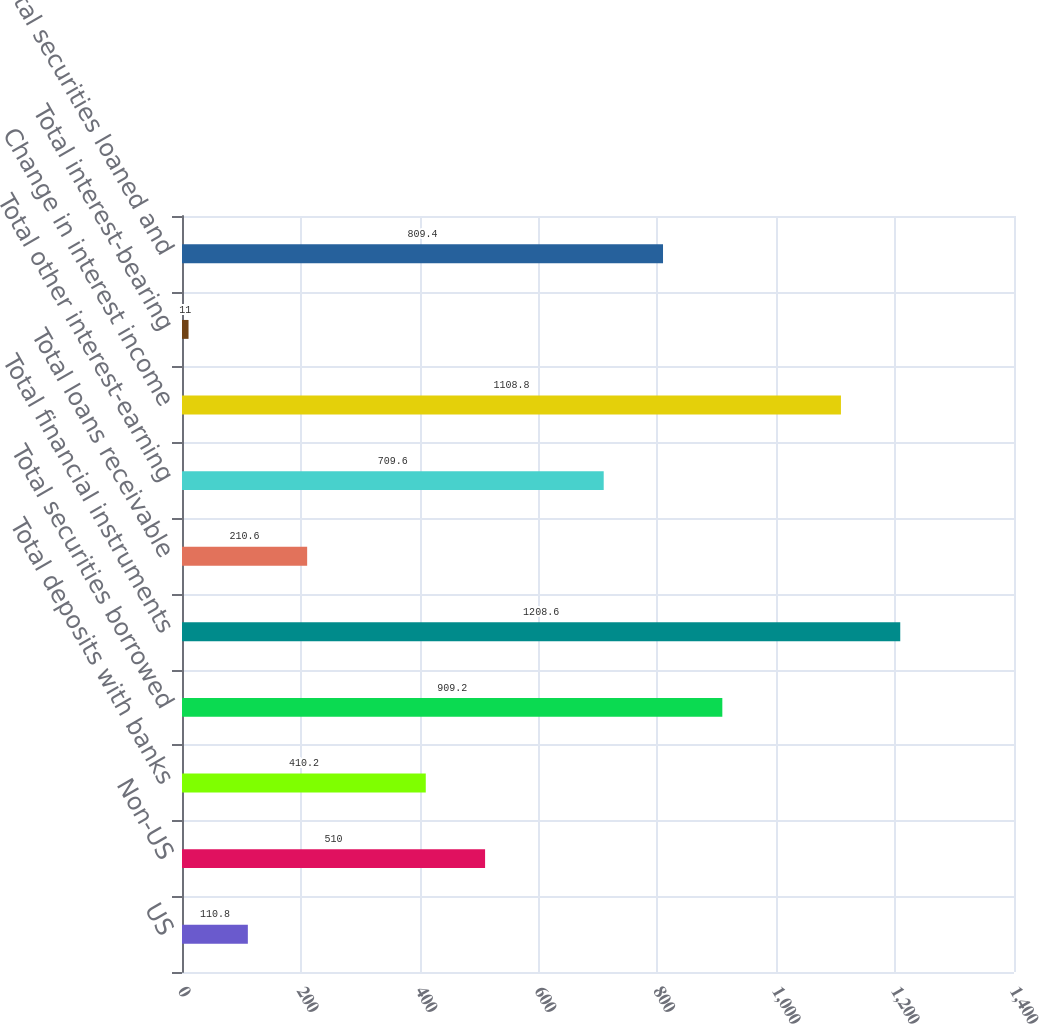<chart> <loc_0><loc_0><loc_500><loc_500><bar_chart><fcel>US<fcel>Non-US<fcel>Total deposits with banks<fcel>Total securities borrowed<fcel>Total financial instruments<fcel>Total loans receivable<fcel>Total other interest-earning<fcel>Change in interest income<fcel>Total interest-bearing<fcel>Total securities loaned and<nl><fcel>110.8<fcel>510<fcel>410.2<fcel>909.2<fcel>1208.6<fcel>210.6<fcel>709.6<fcel>1108.8<fcel>11<fcel>809.4<nl></chart> 